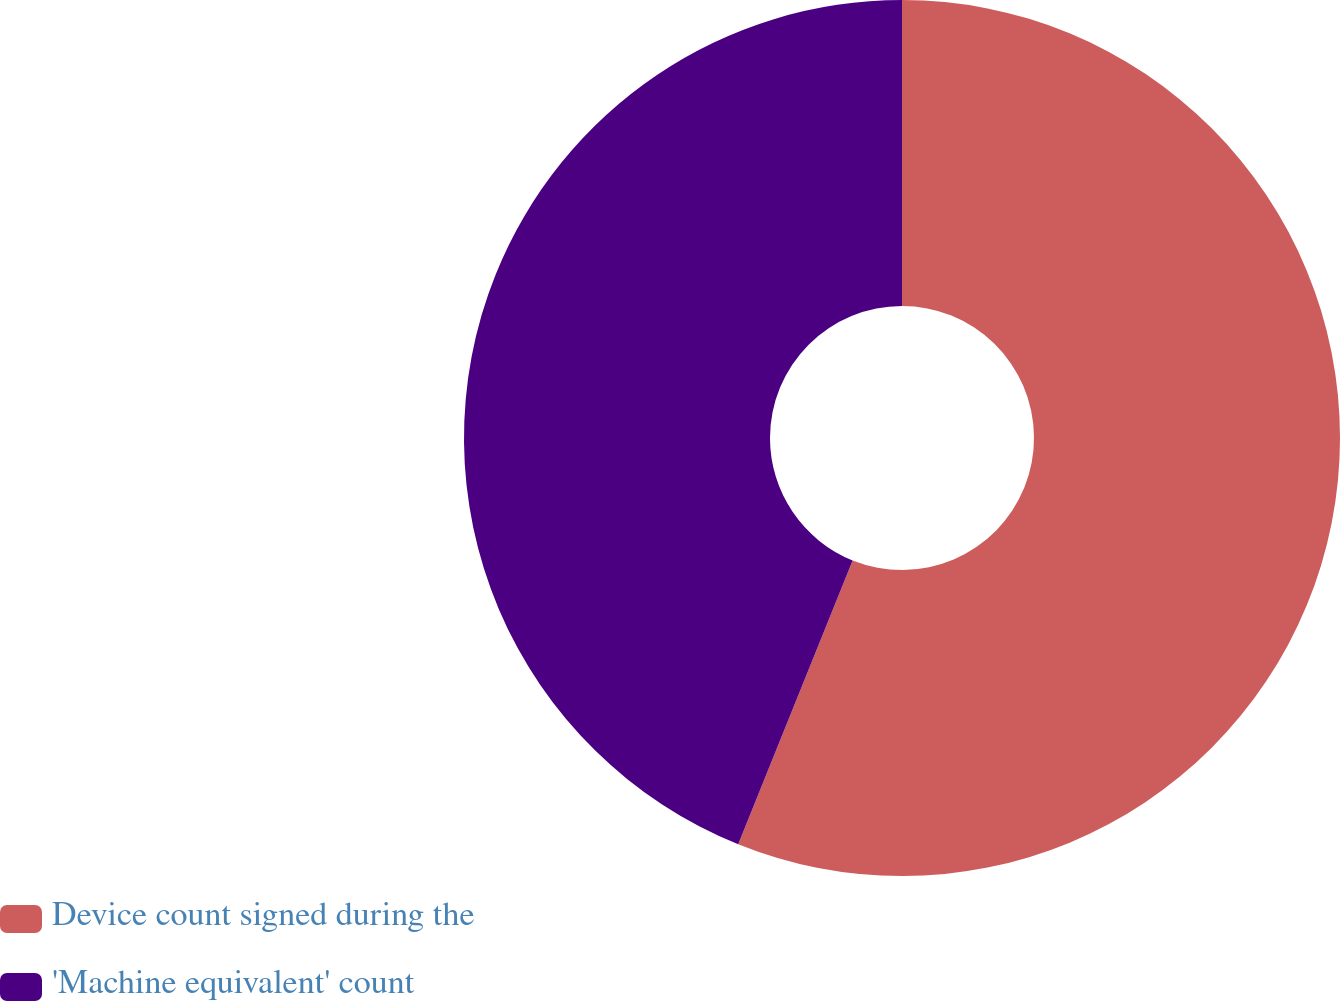<chart> <loc_0><loc_0><loc_500><loc_500><pie_chart><fcel>Device count signed during the<fcel>'Machine equivalent' count<nl><fcel>56.1%<fcel>43.9%<nl></chart> 